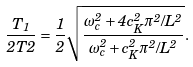<formula> <loc_0><loc_0><loc_500><loc_500>\frac { T _ { 1 } } { 2 T 2 } = \frac { 1 } { 2 } \sqrt { \frac { \omega _ { c } ^ { 2 } + 4 c _ { K } ^ { 2 } \pi ^ { 2 } / L ^ { 2 } } { \omega _ { c } ^ { 2 } + c _ { K } ^ { 2 } \pi ^ { 2 } / L ^ { 2 } } } .</formula> 